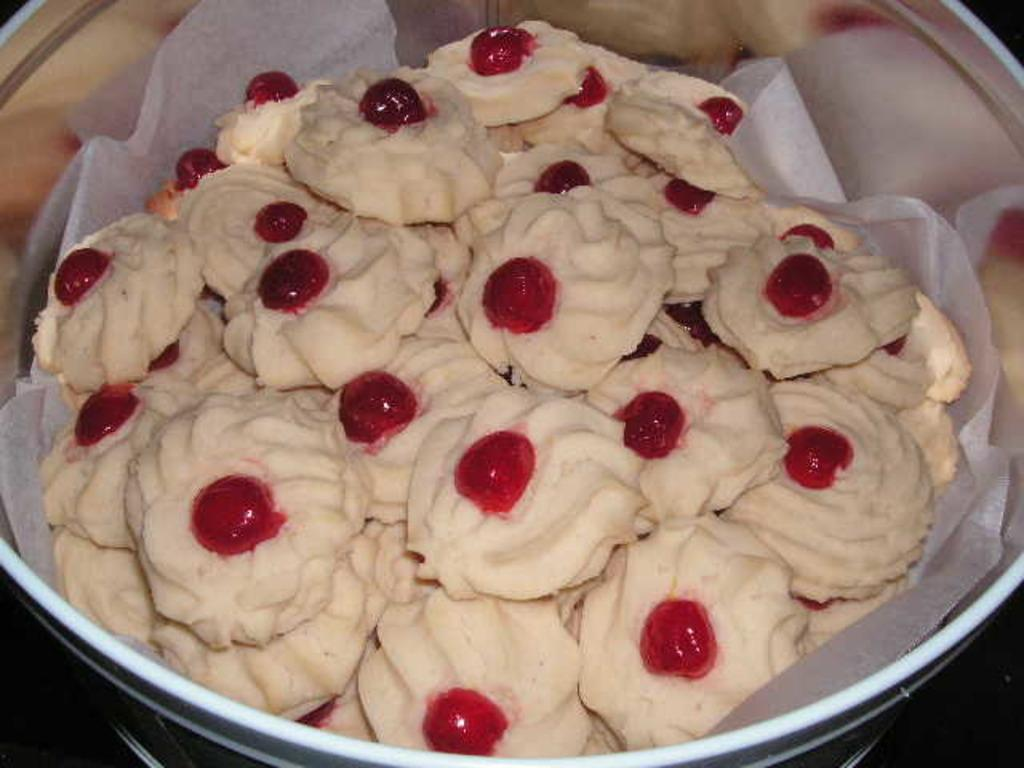What object can be seen in the image that is used for a specific purpose? There is an utensil in the image. What is placed inside the utensil? There is a white paper in the utensil. What color are the items inside the utensil? There are white color things in the utensil. What additional detail can be observed on the white items? There are red dots on the white items. What activity is the mother doing with the balls in the image? There is no mother or balls present in the image. 